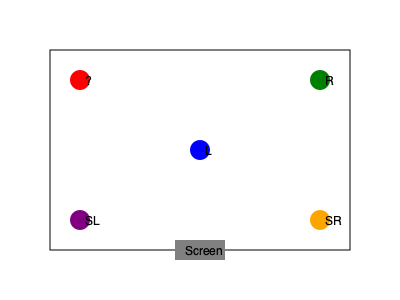In a 5.1 surround sound setup for a recording studio, which speaker should be placed at the position marked with a question mark? To determine the correct placement of speakers in a 5.1 surround sound setup, we need to follow these steps:

1. Identify the standard 5.1 surround sound speaker configuration:
   - Center (C)
   - Left (L) and Right (R) front speakers
   - Left Surround (SL) and Right Surround (SR) rear speakers
   - Subwoofer (not shown in this diagram)

2. Analyze the given diagram:
   - The screen is at the bottom, indicating the front of the room
   - 'L' is placed in the center front, which is incorrect for a standard setup
   - 'R' is correctly placed at the front right
   - 'SL' and 'SR' are correctly placed at the rear left and right

3. Determine the missing speaker:
   - We have L, R, SL, and SR accounted for
   - The center channel (C) is typically placed above or below the screen
   - The only standard position left is the front left, where the question mark is

4. Conclude the correct placement:
   - The speaker marked with a question mark should be the Left (L) front speaker
   - The current 'L' speaker in the center front should actually be the Center (C) speaker

This arrangement would correct the setup to match a standard 5.1 surround sound configuration, crucial for accurate mixing and playback in a recording studio environment.
Answer: Left (L) front speaker 